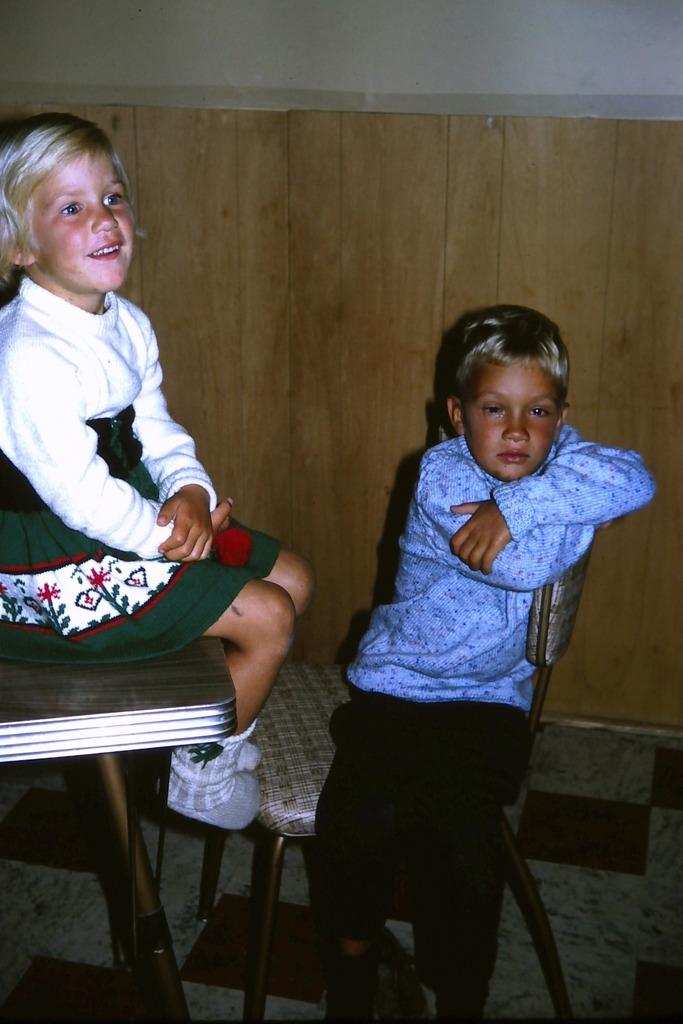How many children are in the image? There are two children in the image. Can you describe the children in the image? One of the children is a girl, and the other child is a boy. What are the children doing in the image? Both the girl and the boy are sitting on a chair. What type of hose is being used by the children in the image? There is no hose present in the image; the children are sitting on a chair. How does the van help the children in the image? There is no van present in the image, so it cannot help the children. 